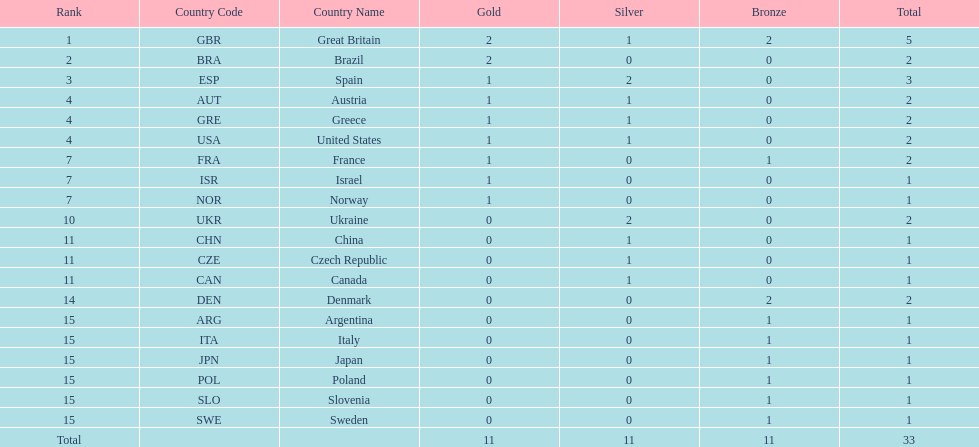How many gold medals did italy receive? 0. 